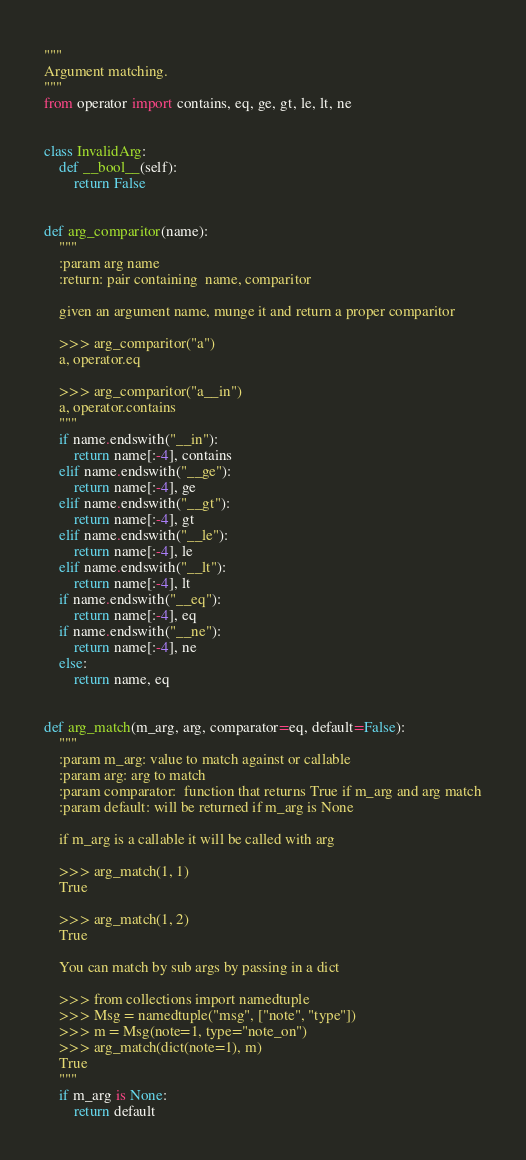Convert code to text. <code><loc_0><loc_0><loc_500><loc_500><_Python_>"""
Argument matching.
"""
from operator import contains, eq, ge, gt, le, lt, ne


class InvalidArg:
    def __bool__(self):
        return False


def arg_comparitor(name):
    """
    :param arg name
    :return: pair containing  name, comparitor

    given an argument name, munge it and return a proper comparitor

    >>> arg_comparitor("a")
    a, operator.eq

    >>> arg_comparitor("a__in")
    a, operator.contains
    """
    if name.endswith("__in"):
        return name[:-4], contains
    elif name.endswith("__ge"):
        return name[:-4], ge
    elif name.endswith("__gt"):
        return name[:-4], gt
    elif name.endswith("__le"):
        return name[:-4], le
    elif name.endswith("__lt"):
        return name[:-4], lt
    if name.endswith("__eq"):
        return name[:-4], eq
    if name.endswith("__ne"):
        return name[:-4], ne
    else:
        return name, eq


def arg_match(m_arg, arg, comparator=eq, default=False):
    """
    :param m_arg: value to match against or callable
    :param arg: arg to match
    :param comparator:  function that returns True if m_arg and arg match
    :param default: will be returned if m_arg is None

    if m_arg is a callable it will be called with arg

    >>> arg_match(1, 1)
    True

    >>> arg_match(1, 2)
    True

    You can match by sub args by passing in a dict

    >>> from collections import namedtuple
    >>> Msg = namedtuple("msg", ["note", "type"])
    >>> m = Msg(note=1, type="note_on")
    >>> arg_match(dict(note=1), m)
    True
    """
    if m_arg is None:
        return default</code> 